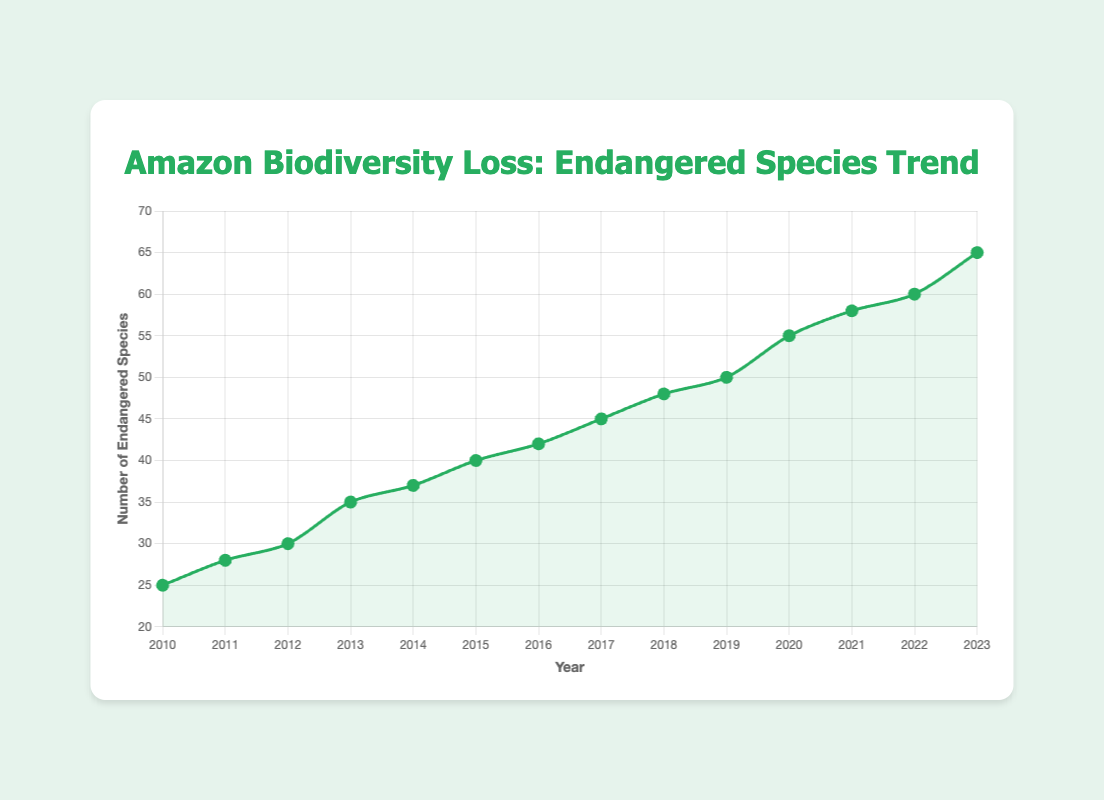What is the total number of endangered species recorded from 2020 to 2023? Add the number of endangered species from 2020, 2021, 2022, and 2023. The values are 55, 58, 60, and 65 respectively. 55 + 58 + 60 + 65 = 238
Answer: 238 In which year did the number of endangered species first reach 50? Look at the line chart and see which year the y-value first reaches or exceeds 50. According to the data, this happens in 2019.
Answer: 2019 By how much did the number of endangered species increase from 2010 to 2023? Subtract the number of endangered species in 2010 from the number in 2023. 65 (in 2023) - 25 (in 2010) = 40
Answer: 40 Which year had a higher number of endangered species, 2015 or 2016? Compare the data points for the years 2015 and 2016. The number of endangered species in 2015 is 40, while in 2016 it is 42.
Answer: 2016 What is the average number of endangered species recorded between 2010 and 2023? First, sum all the number of endangered species from each year (25+28+30+35+37+40+42+45+48+50+55+58+60+65=618). Then, divide by the number of years (14). The average is 618/14 ≈ 44.14
Answer: 44.14 What is the difference in the number of endangered species between 2012 and 2013? Subtract the number of endangered species in 2012 from that in 2013. 35 (in 2013) - 30 (in 2012) = 5
Answer: 5 At what rate is the number of endangered species increasing annually from 2010 to 2023? Calculate the total increase in the number of endangered species over the period (65 - 25 = 40) and divide by the number of years (2023 - 2010 = 13). The rate is 40 / 13 ≈ 3.08 species per year
Answer: 3.08 species per year Which two consecutive years had the smallest increase in the number of endangered species? Examine the increases year by year to find the smallest. The increases are: 
2010-2011: 3, 
2011-2012: 2, 
2012-2013: 5, 
2013-2014: 2, 
2014-2015: 3, 
2015-2016: 2, 
2016-2017: 3, 
2017-2018: 3, 
2018-2019: 2, 
2019-2020: 5, 
2020-2021: 3, 
2021-2022: 2, 
2022-2023: 5. The smallest increases are in the years: 2011-2012, 2013-2014, 2015-2016, 2018-2019, 2021-2022
Answer: 2011-2012, 2013-2014, 2015-2016, 2018-2019, 2021-2022 By how much did the number of endangered species increase from 2014 to 2015? Subtract the number of endangered species in 2014 from that in 2015. 40 (in 2015) - 37 (in 2014) = 3
Answer: 3 